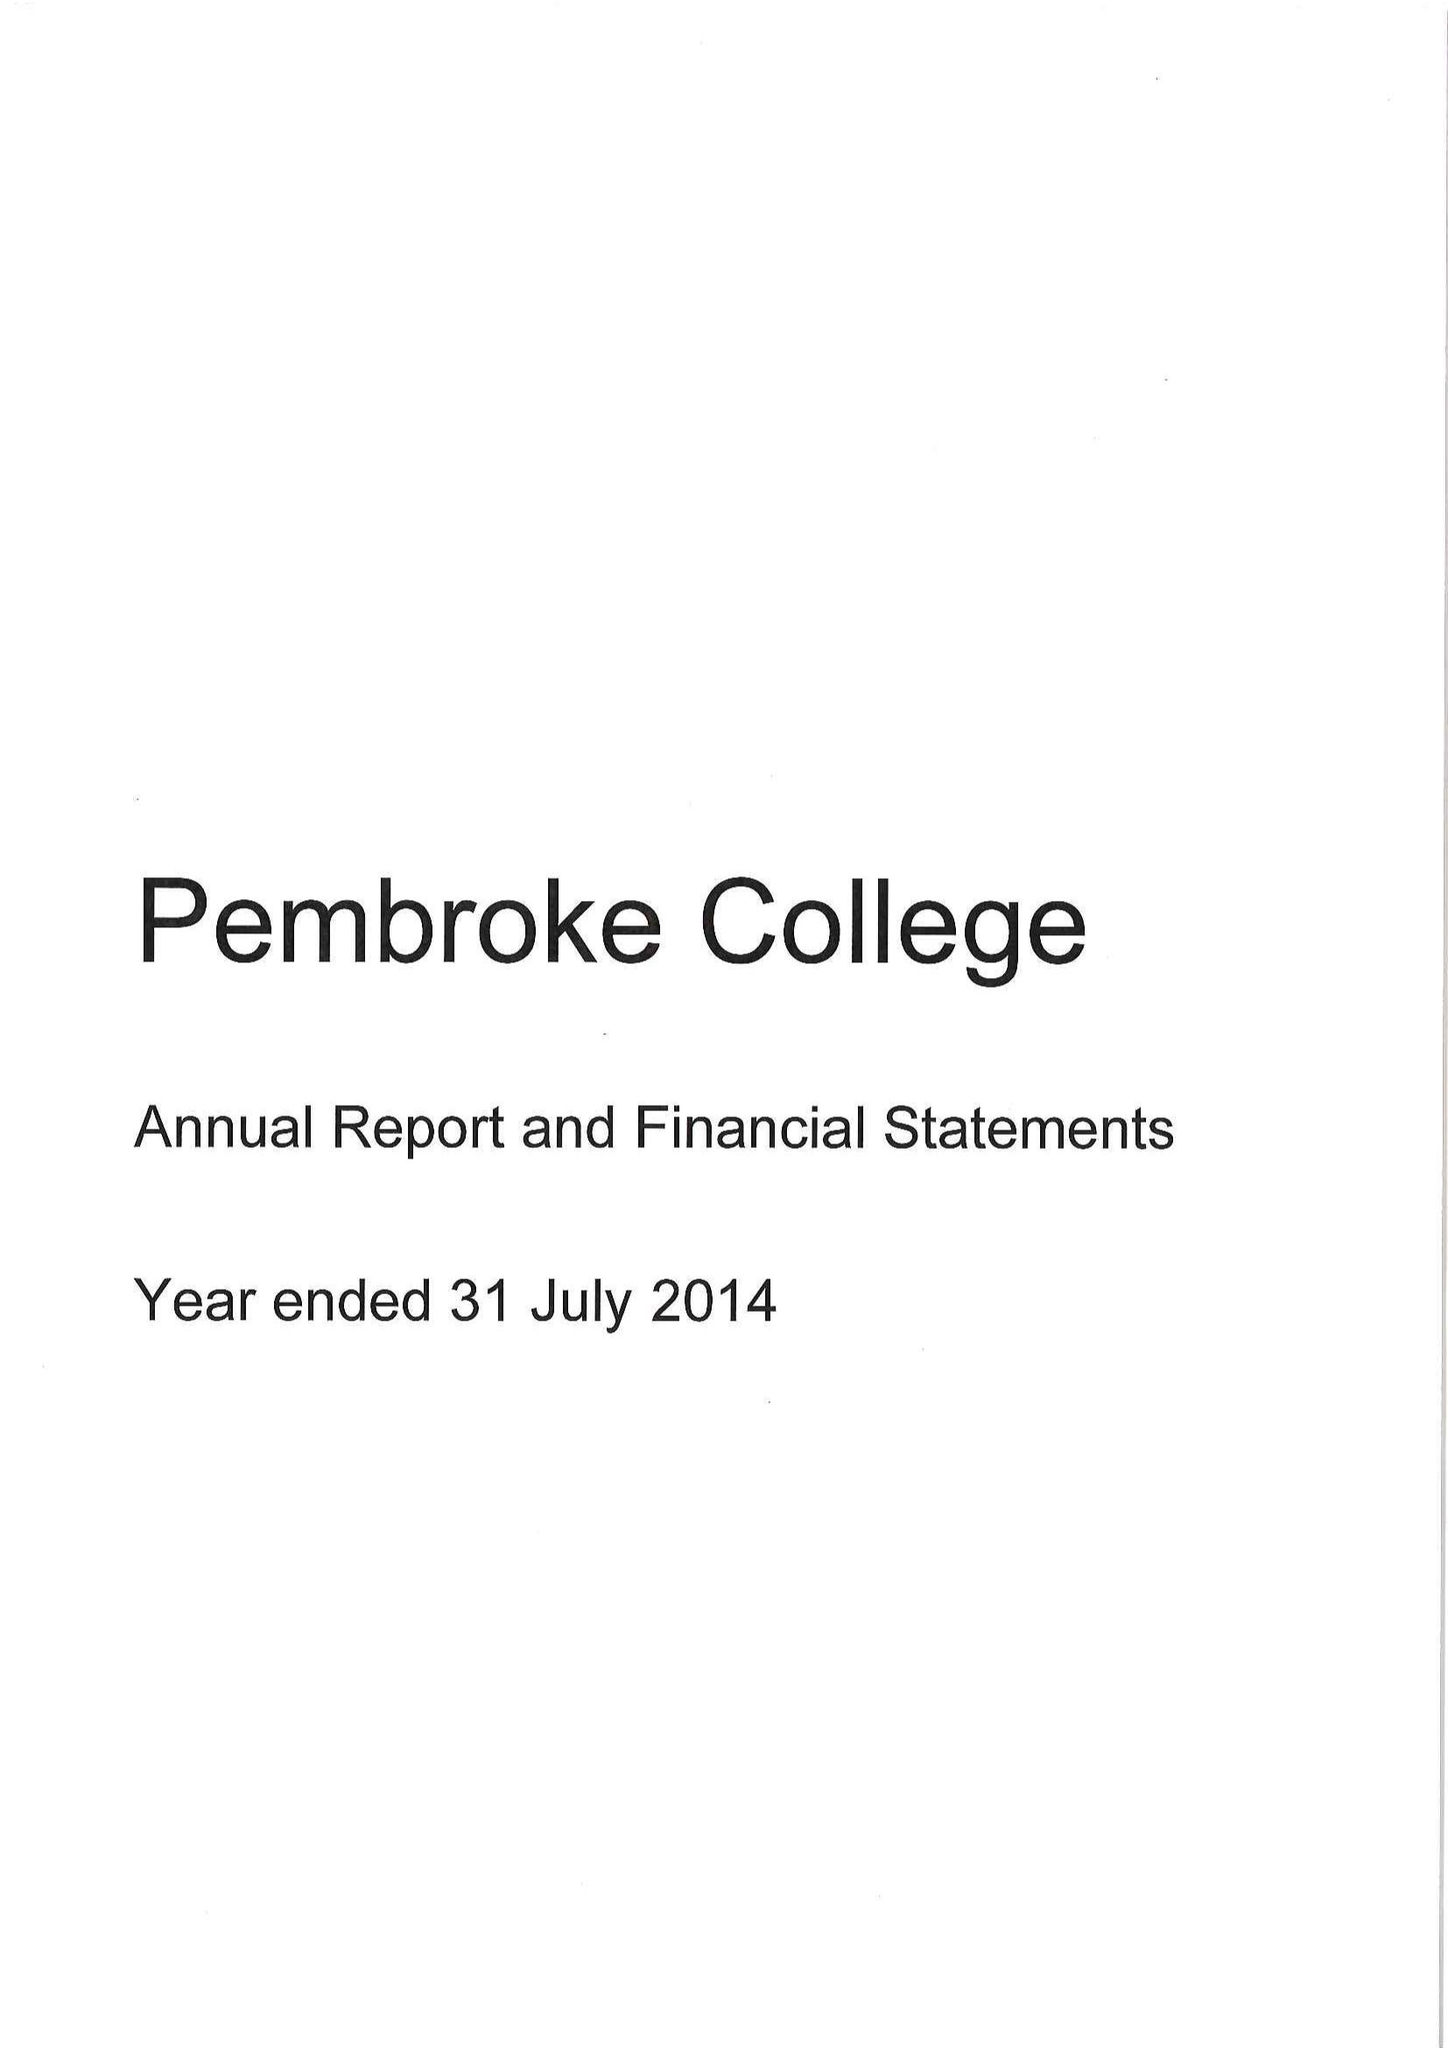What is the value for the income_annually_in_british_pounds?
Answer the question using a single word or phrase. 10763000.00 